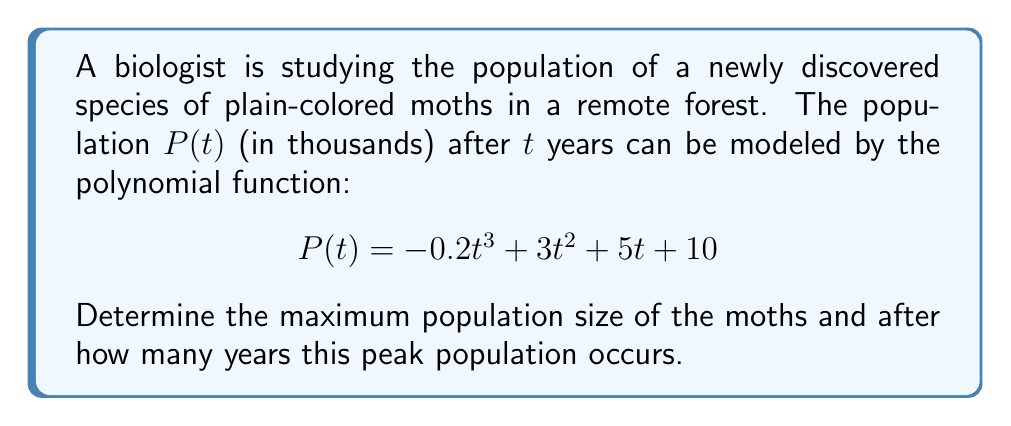Give your solution to this math problem. To find the maximum population and when it occurs, we need to follow these steps:

1) The maximum point of a polynomial function occurs at a critical point where the first derivative equals zero. Let's find the first derivative of $P(t)$:

   $$P'(t) = -0.6t^2 + 6t + 5$$

2) Set $P'(t) = 0$ and solve for $t$:

   $$-0.6t^2 + 6t + 5 = 0$$

3) This is a quadratic equation. We can solve it using the quadratic formula:
   $t = \frac{-b \pm \sqrt{b^2 - 4ac}}{2a}$, where $a = -0.6$, $b = 6$, and $c = 5$

   $$t = \frac{-6 \pm \sqrt{36 - 4(-0.6)(5)}}{2(-0.6)}$$
   $$t = \frac{-6 \pm \sqrt{48}}{-1.2}$$
   $$t = \frac{-6 \pm 6.93}{-1.2}$$

4) This gives us two solutions:
   $t_1 = \frac{-6 + 6.93}{-1.2} \approx 0.775$ and $t_2 = \frac{-6 - 6.93}{-1.2} \approx 10.775$

5) To determine which of these is the maximum (rather than the minimum), we can check the second derivative:

   $$P''(t) = -1.2t + 6$$

   At $t = 0.775$, $P''(0.775) = 5.07 > 0$, indicating a minimum.
   At $t = 10.775$, $P''(10.775) = -6.93 < 0$, indicating a maximum.

6) Therefore, the maximum occurs at $t \approx 10.775$ years.

7) To find the maximum population, we substitute this value back into the original function:

   $$P(10.775) = -0.2(10.775)^3 + 3(10.775)^2 + 5(10.775) + 10$$
   $$\approx 149.6$$

Thus, the maximum population is approximately 149,600 moths.
Answer: The maximum population of moths is approximately 149,600, occurring after about 10.8 years. 